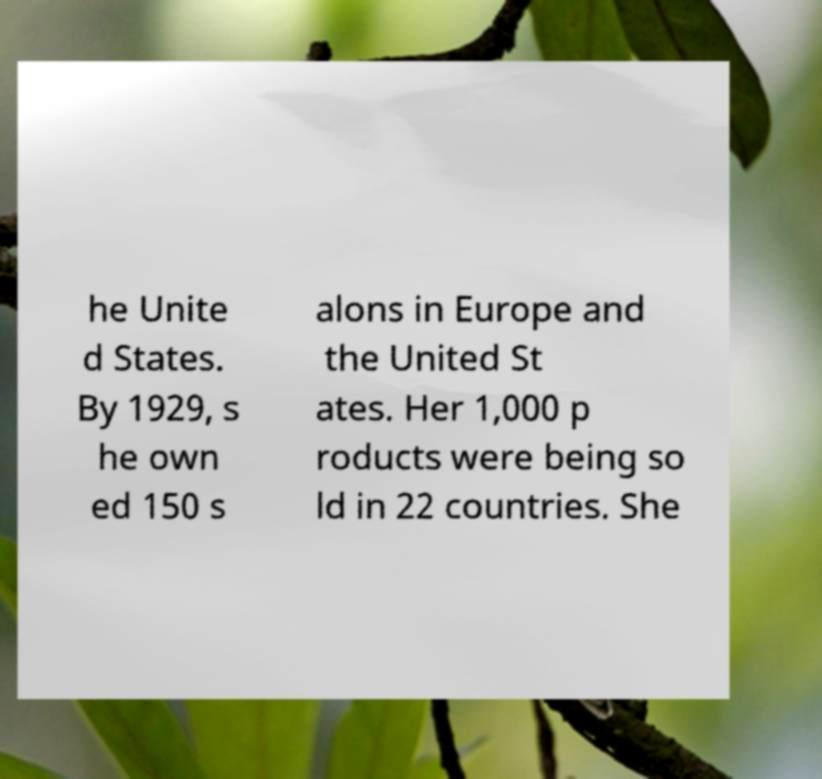Could you extract and type out the text from this image? he Unite d States. By 1929, s he own ed 150 s alons in Europe and the United St ates. Her 1,000 p roducts were being so ld in 22 countries. She 